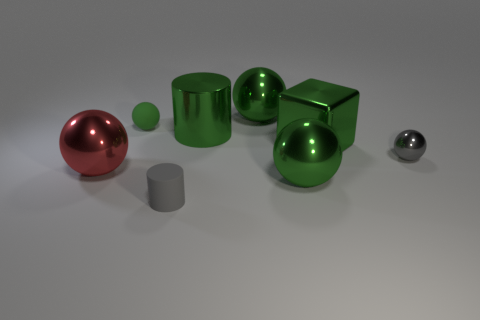Subtract all large green shiny balls. How many balls are left? 3 Subtract 1 cylinders. How many cylinders are left? 1 Add 2 tiny cylinders. How many objects exist? 10 Subtract all gray cylinders. How many cylinders are left? 1 Subtract 0 purple cubes. How many objects are left? 8 Subtract all spheres. How many objects are left? 3 Subtract all blue balls. Subtract all cyan cubes. How many balls are left? 5 Subtract all blue cylinders. How many blue blocks are left? 0 Subtract all large gray metal cubes. Subtract all tiny rubber balls. How many objects are left? 7 Add 4 small gray rubber cylinders. How many small gray rubber cylinders are left? 5 